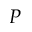<formula> <loc_0><loc_0><loc_500><loc_500>P</formula> 